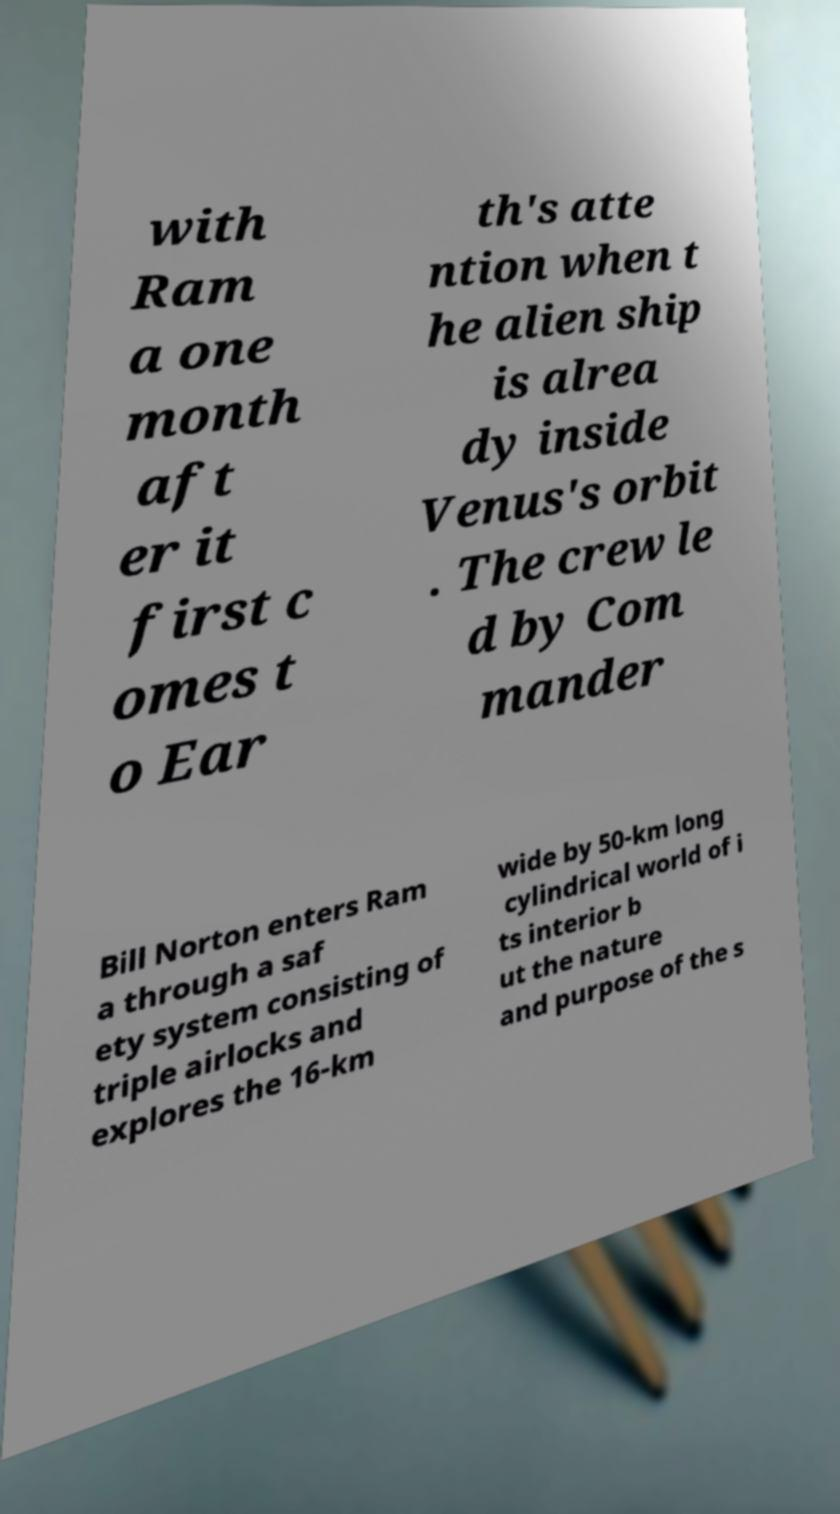Please read and relay the text visible in this image. What does it say? with Ram a one month aft er it first c omes t o Ear th's atte ntion when t he alien ship is alrea dy inside Venus's orbit . The crew le d by Com mander Bill Norton enters Ram a through a saf ety system consisting of triple airlocks and explores the 16-km wide by 50-km long cylindrical world of i ts interior b ut the nature and purpose of the s 